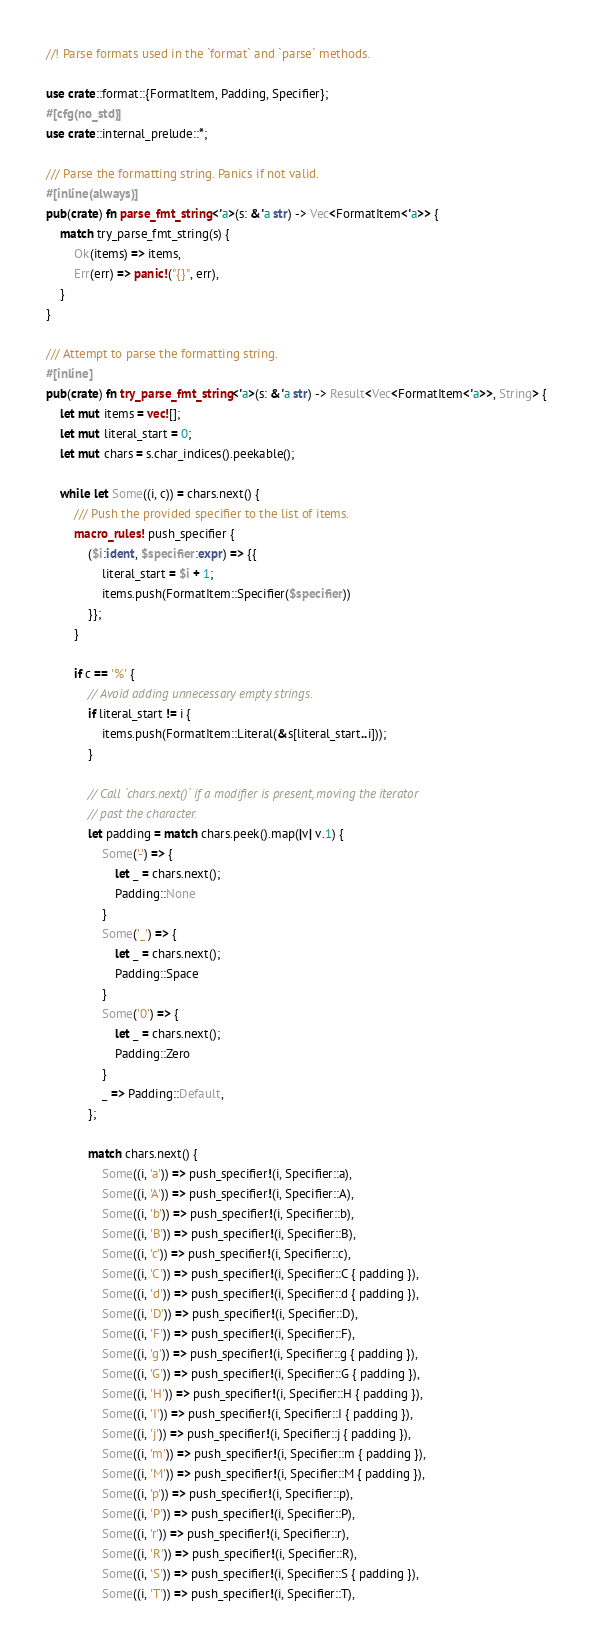Convert code to text. <code><loc_0><loc_0><loc_500><loc_500><_Rust_>//! Parse formats used in the `format` and `parse` methods.

use crate::format::{FormatItem, Padding, Specifier};
#[cfg(no_std)]
use crate::internal_prelude::*;

/// Parse the formatting string. Panics if not valid.
#[inline(always)]
pub(crate) fn parse_fmt_string<'a>(s: &'a str) -> Vec<FormatItem<'a>> {
    match try_parse_fmt_string(s) {
        Ok(items) => items,
        Err(err) => panic!("{}", err),
    }
}

/// Attempt to parse the formatting string.
#[inline]
pub(crate) fn try_parse_fmt_string<'a>(s: &'a str) -> Result<Vec<FormatItem<'a>>, String> {
    let mut items = vec![];
    let mut literal_start = 0;
    let mut chars = s.char_indices().peekable();

    while let Some((i, c)) = chars.next() {
        /// Push the provided specifier to the list of items.
        macro_rules! push_specifier {
            ($i:ident, $specifier:expr) => {{
                literal_start = $i + 1;
                items.push(FormatItem::Specifier($specifier))
            }};
        }

        if c == '%' {
            // Avoid adding unnecessary empty strings.
            if literal_start != i {
                items.push(FormatItem::Literal(&s[literal_start..i]));
            }

            // Call `chars.next()` if a modifier is present, moving the iterator
            // past the character.
            let padding = match chars.peek().map(|v| v.1) {
                Some('-') => {
                    let _ = chars.next();
                    Padding::None
                }
                Some('_') => {
                    let _ = chars.next();
                    Padding::Space
                }
                Some('0') => {
                    let _ = chars.next();
                    Padding::Zero
                }
                _ => Padding::Default,
            };

            match chars.next() {
                Some((i, 'a')) => push_specifier!(i, Specifier::a),
                Some((i, 'A')) => push_specifier!(i, Specifier::A),
                Some((i, 'b')) => push_specifier!(i, Specifier::b),
                Some((i, 'B')) => push_specifier!(i, Specifier::B),
                Some((i, 'c')) => push_specifier!(i, Specifier::c),
                Some((i, 'C')) => push_specifier!(i, Specifier::C { padding }),
                Some((i, 'd')) => push_specifier!(i, Specifier::d { padding }),
                Some((i, 'D')) => push_specifier!(i, Specifier::D),
                Some((i, 'F')) => push_specifier!(i, Specifier::F),
                Some((i, 'g')) => push_specifier!(i, Specifier::g { padding }),
                Some((i, 'G')) => push_specifier!(i, Specifier::G { padding }),
                Some((i, 'H')) => push_specifier!(i, Specifier::H { padding }),
                Some((i, 'I')) => push_specifier!(i, Specifier::I { padding }),
                Some((i, 'j')) => push_specifier!(i, Specifier::j { padding }),
                Some((i, 'm')) => push_specifier!(i, Specifier::m { padding }),
                Some((i, 'M')) => push_specifier!(i, Specifier::M { padding }),
                Some((i, 'p')) => push_specifier!(i, Specifier::p),
                Some((i, 'P')) => push_specifier!(i, Specifier::P),
                Some((i, 'r')) => push_specifier!(i, Specifier::r),
                Some((i, 'R')) => push_specifier!(i, Specifier::R),
                Some((i, 'S')) => push_specifier!(i, Specifier::S { padding }),
                Some((i, 'T')) => push_specifier!(i, Specifier::T),</code> 